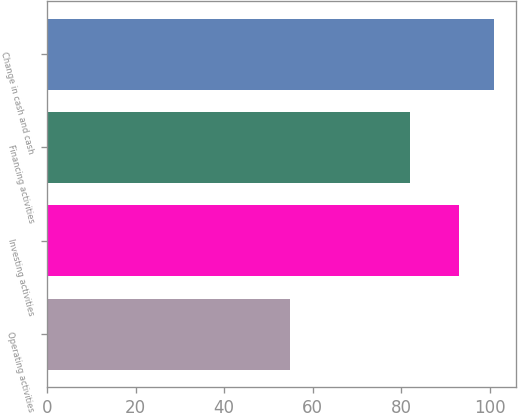Convert chart to OTSL. <chart><loc_0><loc_0><loc_500><loc_500><bar_chart><fcel>Operating activities<fcel>Investing activities<fcel>Financing activities<fcel>Change in cash and cash<nl><fcel>55<fcel>93<fcel>82<fcel>101<nl></chart> 